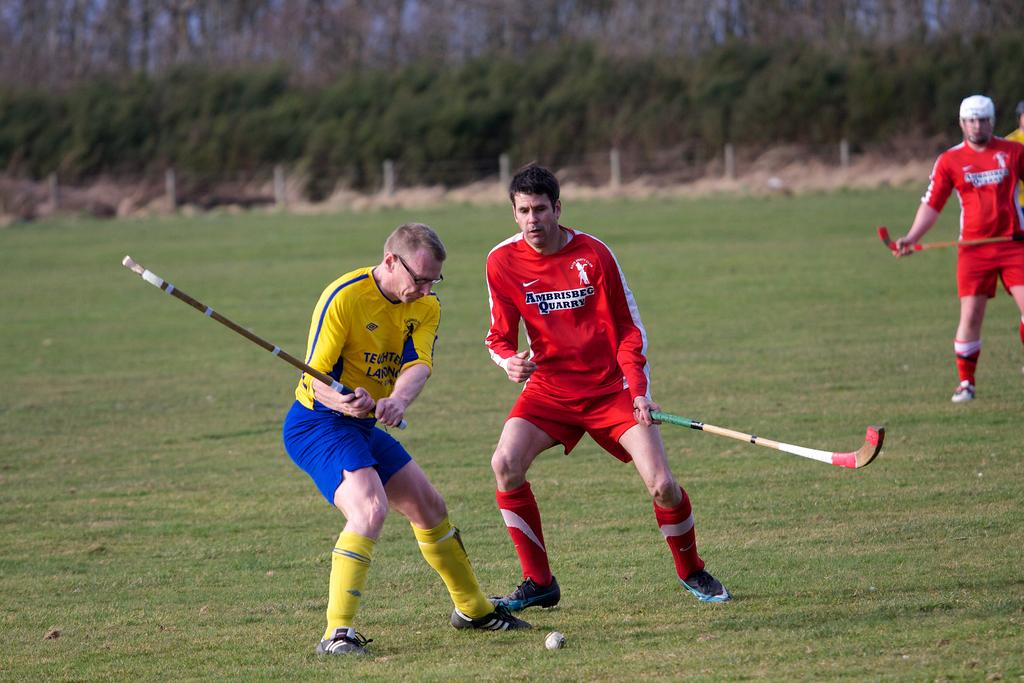How many people are in the image? There is a group of persons in the image. What are the persons wearing? The persons are wearing sports dress. What sport are the persons playing? The persons are playing hockey. What can be seen in the background of the image? There are trees in the background of the image. What type of art can be seen hanging on the trees in the image? There is no art hanging on the trees in the image; only the persons playing hockey and the trees in the background are present. How many pigs are visible in the image? There are no pigs present in the image. 